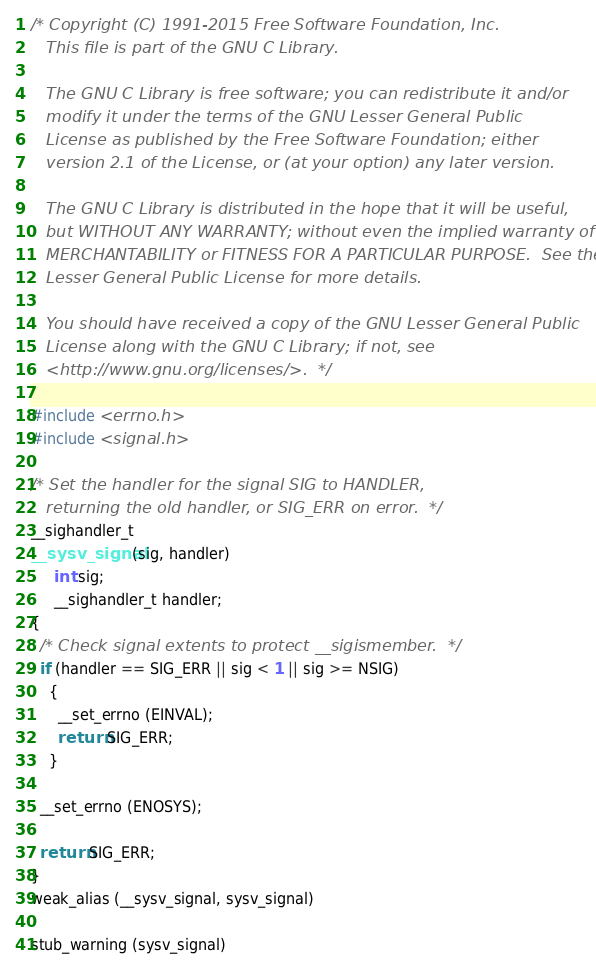Convert code to text. <code><loc_0><loc_0><loc_500><loc_500><_C_>/* Copyright (C) 1991-2015 Free Software Foundation, Inc.
   This file is part of the GNU C Library.

   The GNU C Library is free software; you can redistribute it and/or
   modify it under the terms of the GNU Lesser General Public
   License as published by the Free Software Foundation; either
   version 2.1 of the License, or (at your option) any later version.

   The GNU C Library is distributed in the hope that it will be useful,
   but WITHOUT ANY WARRANTY; without even the implied warranty of
   MERCHANTABILITY or FITNESS FOR A PARTICULAR PURPOSE.  See the GNU
   Lesser General Public License for more details.

   You should have received a copy of the GNU Lesser General Public
   License along with the GNU C Library; if not, see
   <http://www.gnu.org/licenses/>.  */

#include <errno.h>
#include <signal.h>

/* Set the handler for the signal SIG to HANDLER,
   returning the old handler, or SIG_ERR on error.  */
__sighandler_t
__sysv_signal (sig, handler)
     int sig;
     __sighandler_t handler;
{
  /* Check signal extents to protect __sigismember.  */
  if (handler == SIG_ERR || sig < 1 || sig >= NSIG)
    {
      __set_errno (EINVAL);
      return SIG_ERR;
    }

  __set_errno (ENOSYS);

  return SIG_ERR;
}
weak_alias (__sysv_signal, sysv_signal)

stub_warning (sysv_signal)
</code> 